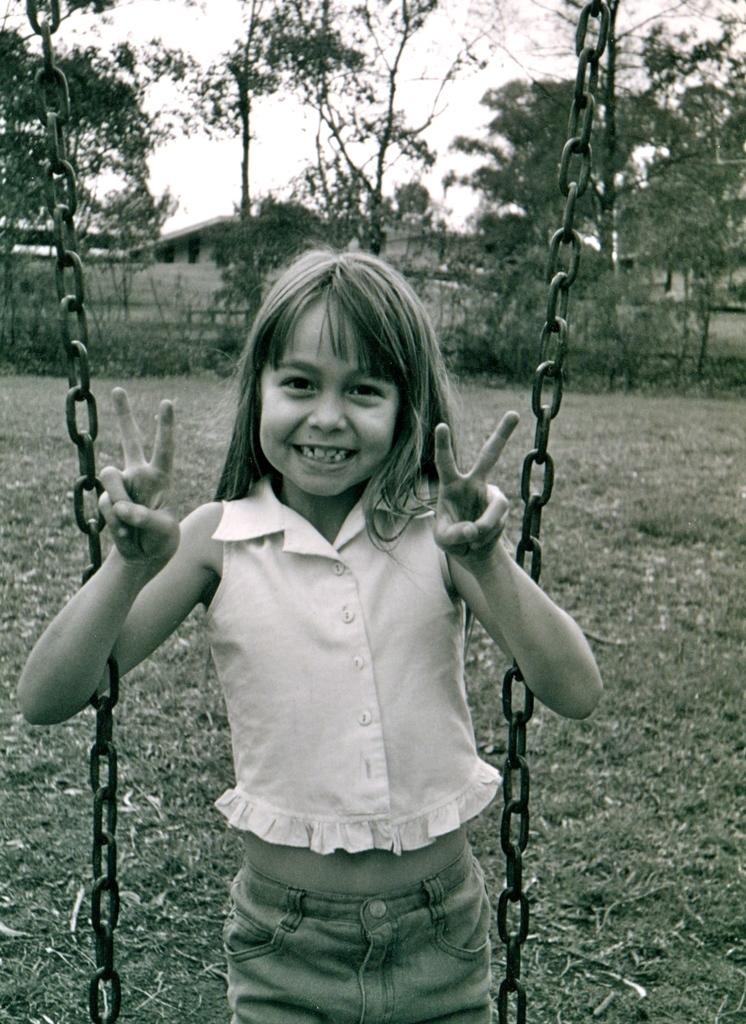Who is present in the image? There is a girl in the image. What is the girl's expression? The girl is smiling. What objects are near the girl? There are chains beside the girl. What can be seen in the distance in the image? There are houses and trees in the background of the image. Where is the faucet located in the image? There is no faucet present in the image. What type of coal is being used to fuel the girl's smile? The girl's smile is not fueled by coal, as it is a natural expression of happiness. 